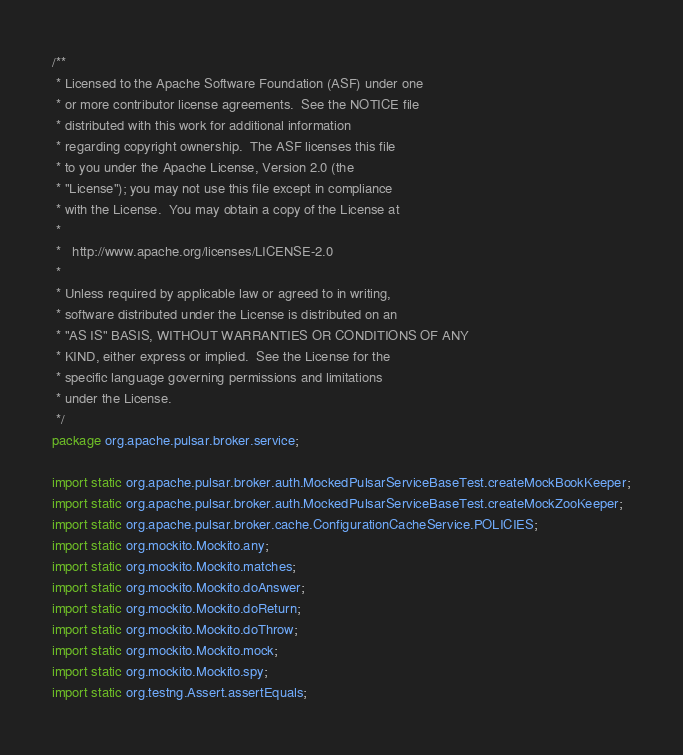Convert code to text. <code><loc_0><loc_0><loc_500><loc_500><_Java_>/**
 * Licensed to the Apache Software Foundation (ASF) under one
 * or more contributor license agreements.  See the NOTICE file
 * distributed with this work for additional information
 * regarding copyright ownership.  The ASF licenses this file
 * to you under the Apache License, Version 2.0 (the
 * "License"); you may not use this file except in compliance
 * with the License.  You may obtain a copy of the License at
 *
 *   http://www.apache.org/licenses/LICENSE-2.0
 *
 * Unless required by applicable law or agreed to in writing,
 * software distributed under the License is distributed on an
 * "AS IS" BASIS, WITHOUT WARRANTIES OR CONDITIONS OF ANY
 * KIND, either express or implied.  See the License for the
 * specific language governing permissions and limitations
 * under the License.
 */
package org.apache.pulsar.broker.service;

import static org.apache.pulsar.broker.auth.MockedPulsarServiceBaseTest.createMockBookKeeper;
import static org.apache.pulsar.broker.auth.MockedPulsarServiceBaseTest.createMockZooKeeper;
import static org.apache.pulsar.broker.cache.ConfigurationCacheService.POLICIES;
import static org.mockito.Mockito.any;
import static org.mockito.Mockito.matches;
import static org.mockito.Mockito.doAnswer;
import static org.mockito.Mockito.doReturn;
import static org.mockito.Mockito.doThrow;
import static org.mockito.Mockito.mock;
import static org.mockito.Mockito.spy;
import static org.testng.Assert.assertEquals;</code> 